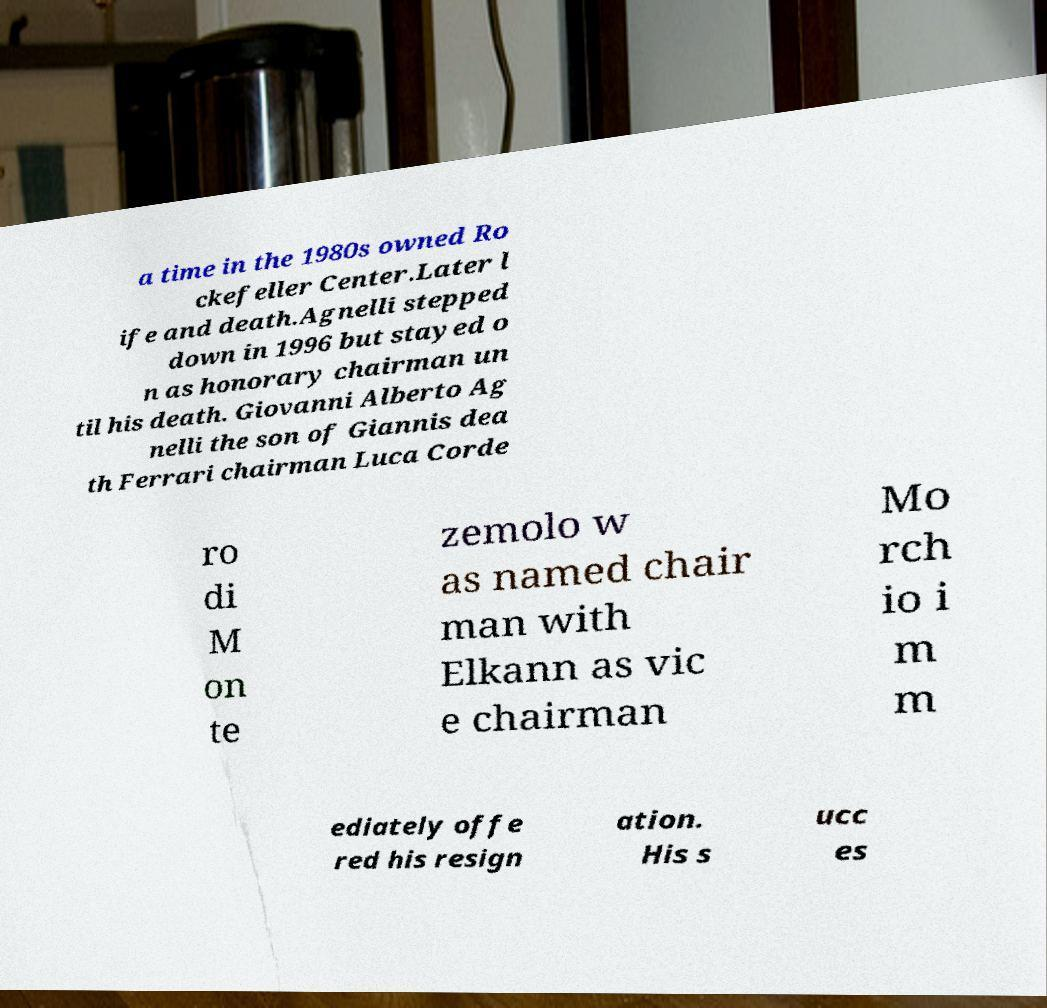For documentation purposes, I need the text within this image transcribed. Could you provide that? a time in the 1980s owned Ro ckefeller Center.Later l ife and death.Agnelli stepped down in 1996 but stayed o n as honorary chairman un til his death. Giovanni Alberto Ag nelli the son of Giannis dea th Ferrari chairman Luca Corde ro di M on te zemolo w as named chair man with Elkann as vic e chairman Mo rch io i m m ediately offe red his resign ation. His s ucc es 